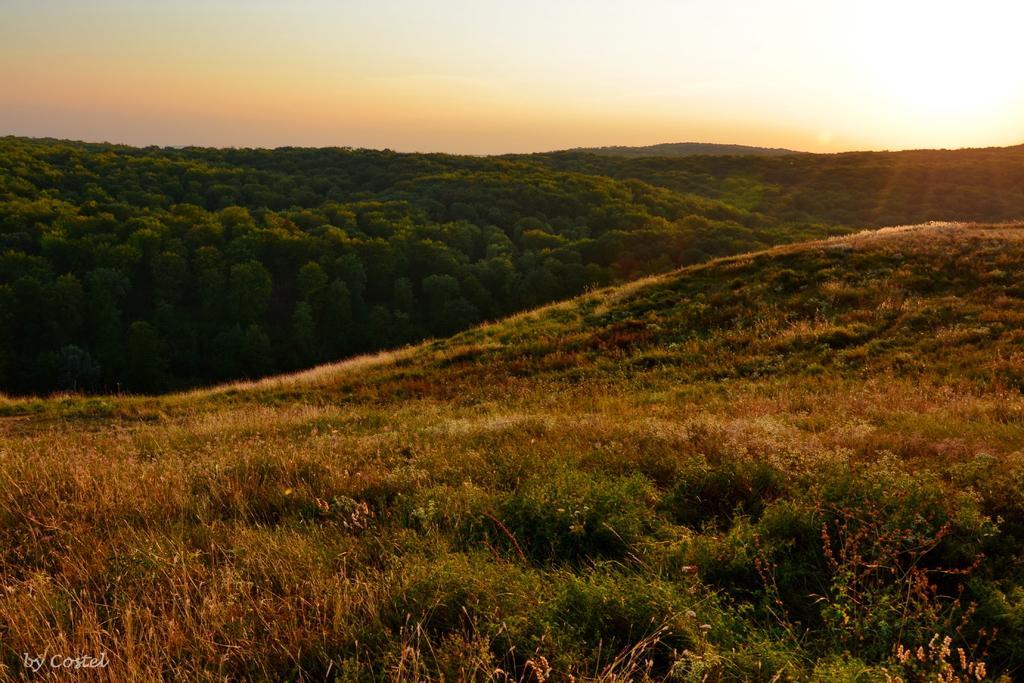How would you summarize this image in a sentence or two? In this image we can see a group of plants and trees on the hills. On the backside we can see the sun and the sky which looks cloudy. 